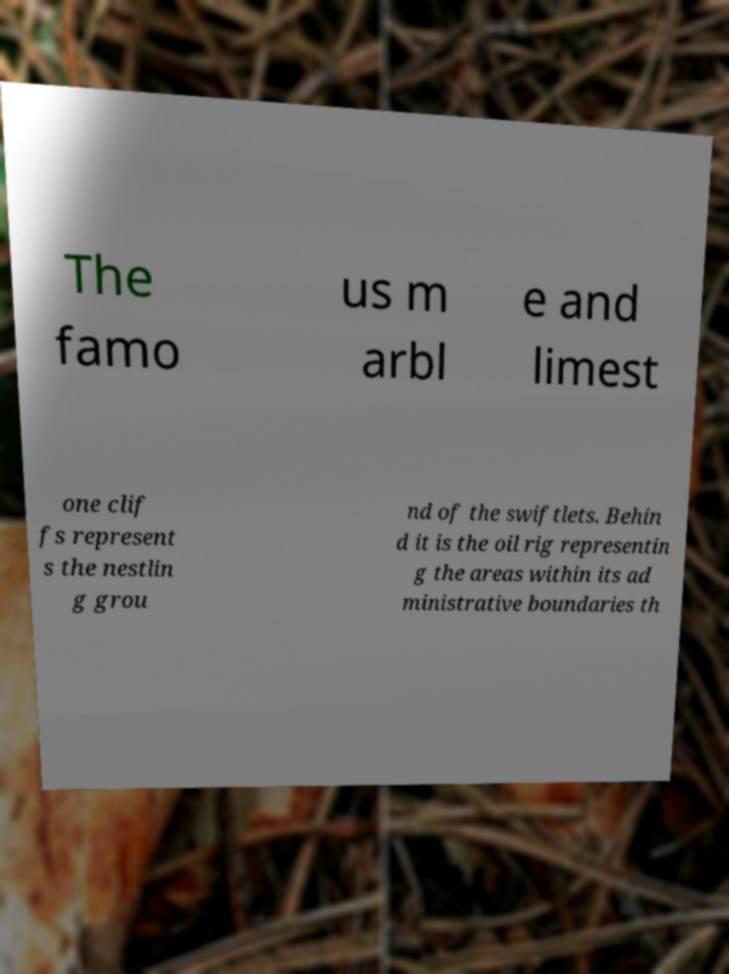Please identify and transcribe the text found in this image. The famo us m arbl e and limest one clif fs represent s the nestlin g grou nd of the swiftlets. Behin d it is the oil rig representin g the areas within its ad ministrative boundaries th 